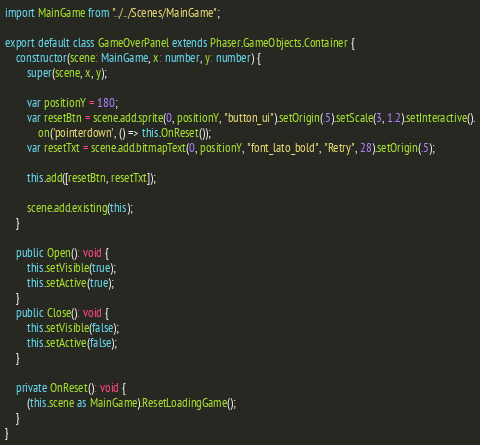Convert code to text. <code><loc_0><loc_0><loc_500><loc_500><_TypeScript_>import MainGame from "../../Scenes/MainGame";

export default class GameOverPanel extends Phaser.GameObjects.Container {
    constructor(scene: MainGame, x: number, y: number) {
        super(scene, x, y);

        var positionY = 180;
        var resetBtn = scene.add.sprite(0, positionY, "button_ui").setOrigin(.5).setScale(3, 1.2).setInteractive().
            on('pointerdown', () => this.OnReset());
        var resetTxt = scene.add.bitmapText(0, positionY, "font_lato_bold", "Retry", 28).setOrigin(.5);

        this.add([resetBtn, resetTxt]);

        scene.add.existing(this);
    }

    public Open(): void {
        this.setVisible(true);
        this.setActive(true);
    }
    public Close(): void {
        this.setVisible(false);
        this.setActive(false);
    }

    private OnReset(): void {
        (this.scene as MainGame).ResetLoadingGame();
    }
}
</code> 